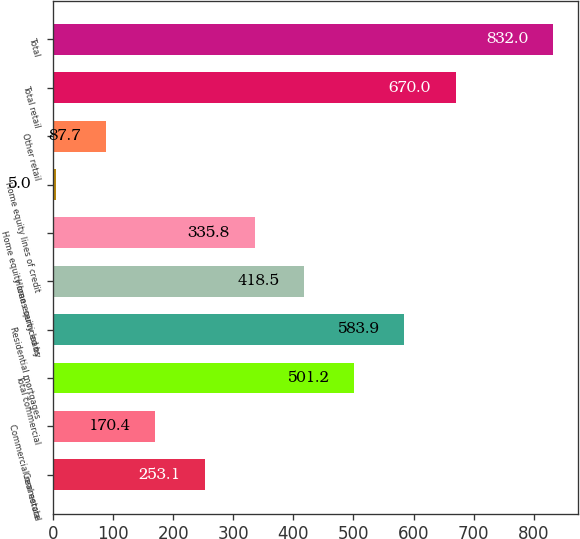<chart> <loc_0><loc_0><loc_500><loc_500><bar_chart><fcel>Commercial<fcel>Commercial real estate<fcel>Total commercial<fcel>Residential mortgages<fcel>Home equity loans<fcel>Home equity loans serviced by<fcel>Home equity lines of credit<fcel>Other retail<fcel>Total retail<fcel>Total<nl><fcel>253.1<fcel>170.4<fcel>501.2<fcel>583.9<fcel>418.5<fcel>335.8<fcel>5<fcel>87.7<fcel>670<fcel>832<nl></chart> 